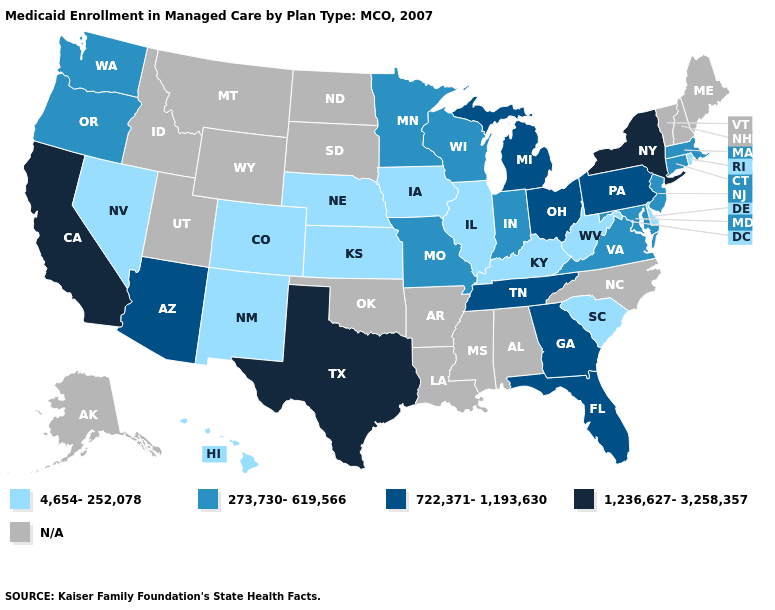Name the states that have a value in the range N/A?
Answer briefly. Alabama, Alaska, Arkansas, Idaho, Louisiana, Maine, Mississippi, Montana, New Hampshire, North Carolina, North Dakota, Oklahoma, South Dakota, Utah, Vermont, Wyoming. Does Pennsylvania have the lowest value in the USA?
Short answer required. No. Name the states that have a value in the range 722,371-1,193,630?
Give a very brief answer. Arizona, Florida, Georgia, Michigan, Ohio, Pennsylvania, Tennessee. What is the value of North Dakota?
Write a very short answer. N/A. What is the lowest value in the USA?
Keep it brief. 4,654-252,078. Which states have the lowest value in the USA?
Be succinct. Colorado, Delaware, Hawaii, Illinois, Iowa, Kansas, Kentucky, Nebraska, Nevada, New Mexico, Rhode Island, South Carolina, West Virginia. Among the states that border Florida , which have the highest value?
Short answer required. Georgia. Does Pennsylvania have the lowest value in the Northeast?
Be succinct. No. Does the first symbol in the legend represent the smallest category?
Short answer required. Yes. Does New York have the highest value in the USA?
Be succinct. Yes. Among the states that border Idaho , which have the lowest value?
Write a very short answer. Nevada. Is the legend a continuous bar?
Quick response, please. No. Name the states that have a value in the range 273,730-619,566?
Concise answer only. Connecticut, Indiana, Maryland, Massachusetts, Minnesota, Missouri, New Jersey, Oregon, Virginia, Washington, Wisconsin. Among the states that border Minnesota , which have the highest value?
Short answer required. Wisconsin. Name the states that have a value in the range 722,371-1,193,630?
Answer briefly. Arizona, Florida, Georgia, Michigan, Ohio, Pennsylvania, Tennessee. 